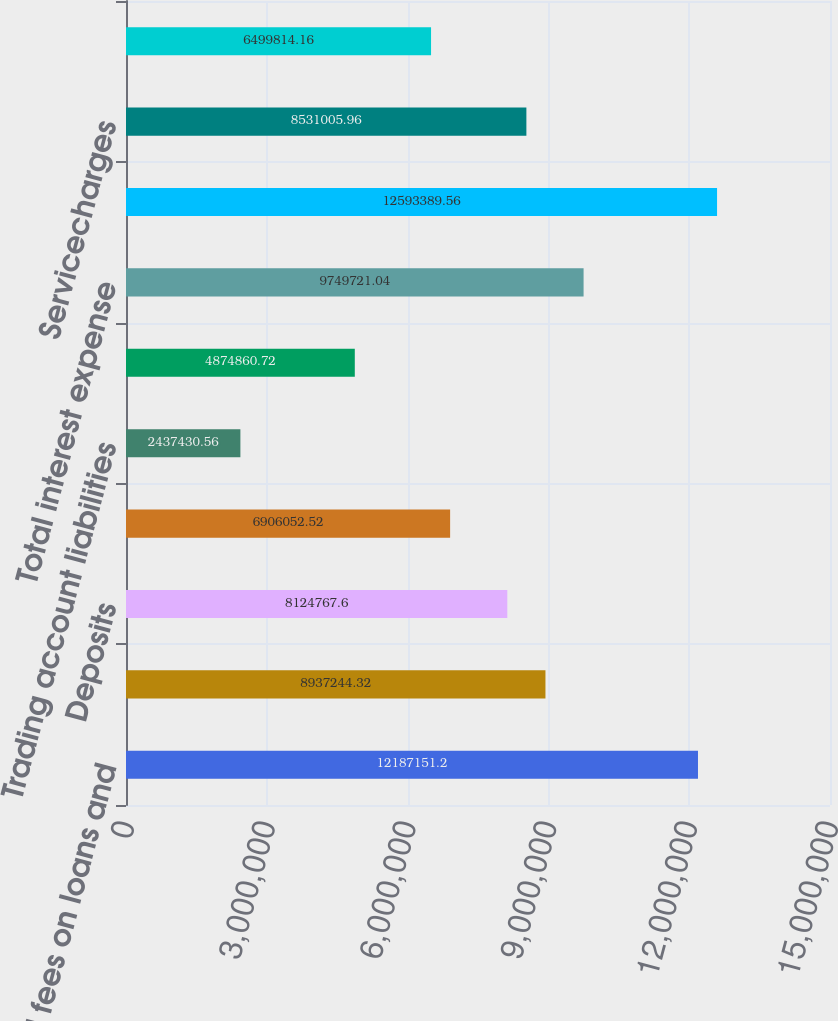Convert chart. <chart><loc_0><loc_0><loc_500><loc_500><bar_chart><fcel>Interest and fees on loans and<fcel>Interest and dividends on<fcel>Deposits<fcel>Short-term borrowings<fcel>Trading account liabilities<fcel>Long-term debt<fcel>Total interest expense<fcel>Net interest income<fcel>Servicecharges<fcel>Investment and brokerage<nl><fcel>1.21872e+07<fcel>8.93724e+06<fcel>8.12477e+06<fcel>6.90605e+06<fcel>2.43743e+06<fcel>4.87486e+06<fcel>9.74972e+06<fcel>1.25934e+07<fcel>8.53101e+06<fcel>6.49981e+06<nl></chart> 